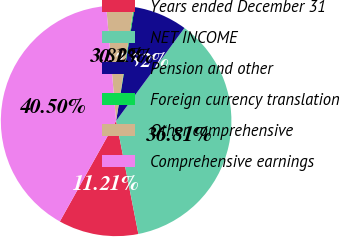Convert chart. <chart><loc_0><loc_0><loc_500><loc_500><pie_chart><fcel>Years ended December 31<fcel>NET INCOME<fcel>Pension and other<fcel>Foreign currency translation<fcel>Other comprehensive<fcel>Comprehensive earnings<nl><fcel>11.21%<fcel>36.81%<fcel>7.52%<fcel>0.13%<fcel>3.82%<fcel>40.5%<nl></chart> 